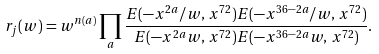<formula> <loc_0><loc_0><loc_500><loc_500>r _ { j } ( w ) = w ^ { n ( a ) } \prod _ { a } \frac { E ( - x ^ { 2 a } / w , \, x ^ { 7 2 } ) E ( - x ^ { 3 6 - 2 a } / w , \, x ^ { 7 2 } ) } { E ( - x ^ { 2 a } w , \, x ^ { 7 2 } ) E ( - x ^ { 3 6 - 2 a } w , \, x ^ { 7 2 } ) } .</formula> 